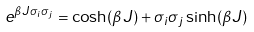<formula> <loc_0><loc_0><loc_500><loc_500>e ^ { \beta J \sigma _ { i } \sigma _ { j } } = \cosh ( \beta J ) + \sigma _ { i } \sigma _ { j } \sinh ( \beta J )</formula> 